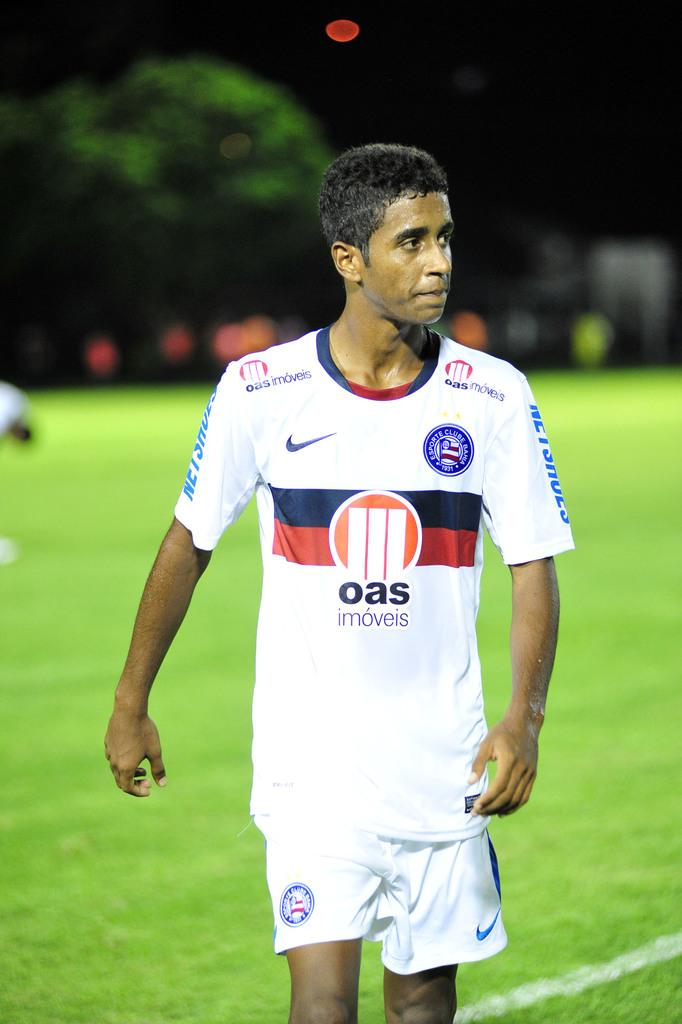Provide a one-sentence caption for the provided image. a soccer player in a white jersey with OAS on the front. 